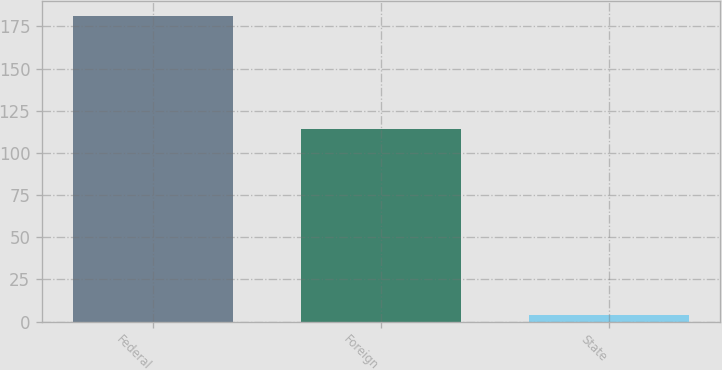<chart> <loc_0><loc_0><loc_500><loc_500><bar_chart><fcel>Federal<fcel>Foreign<fcel>State<nl><fcel>181<fcel>114<fcel>4<nl></chart> 